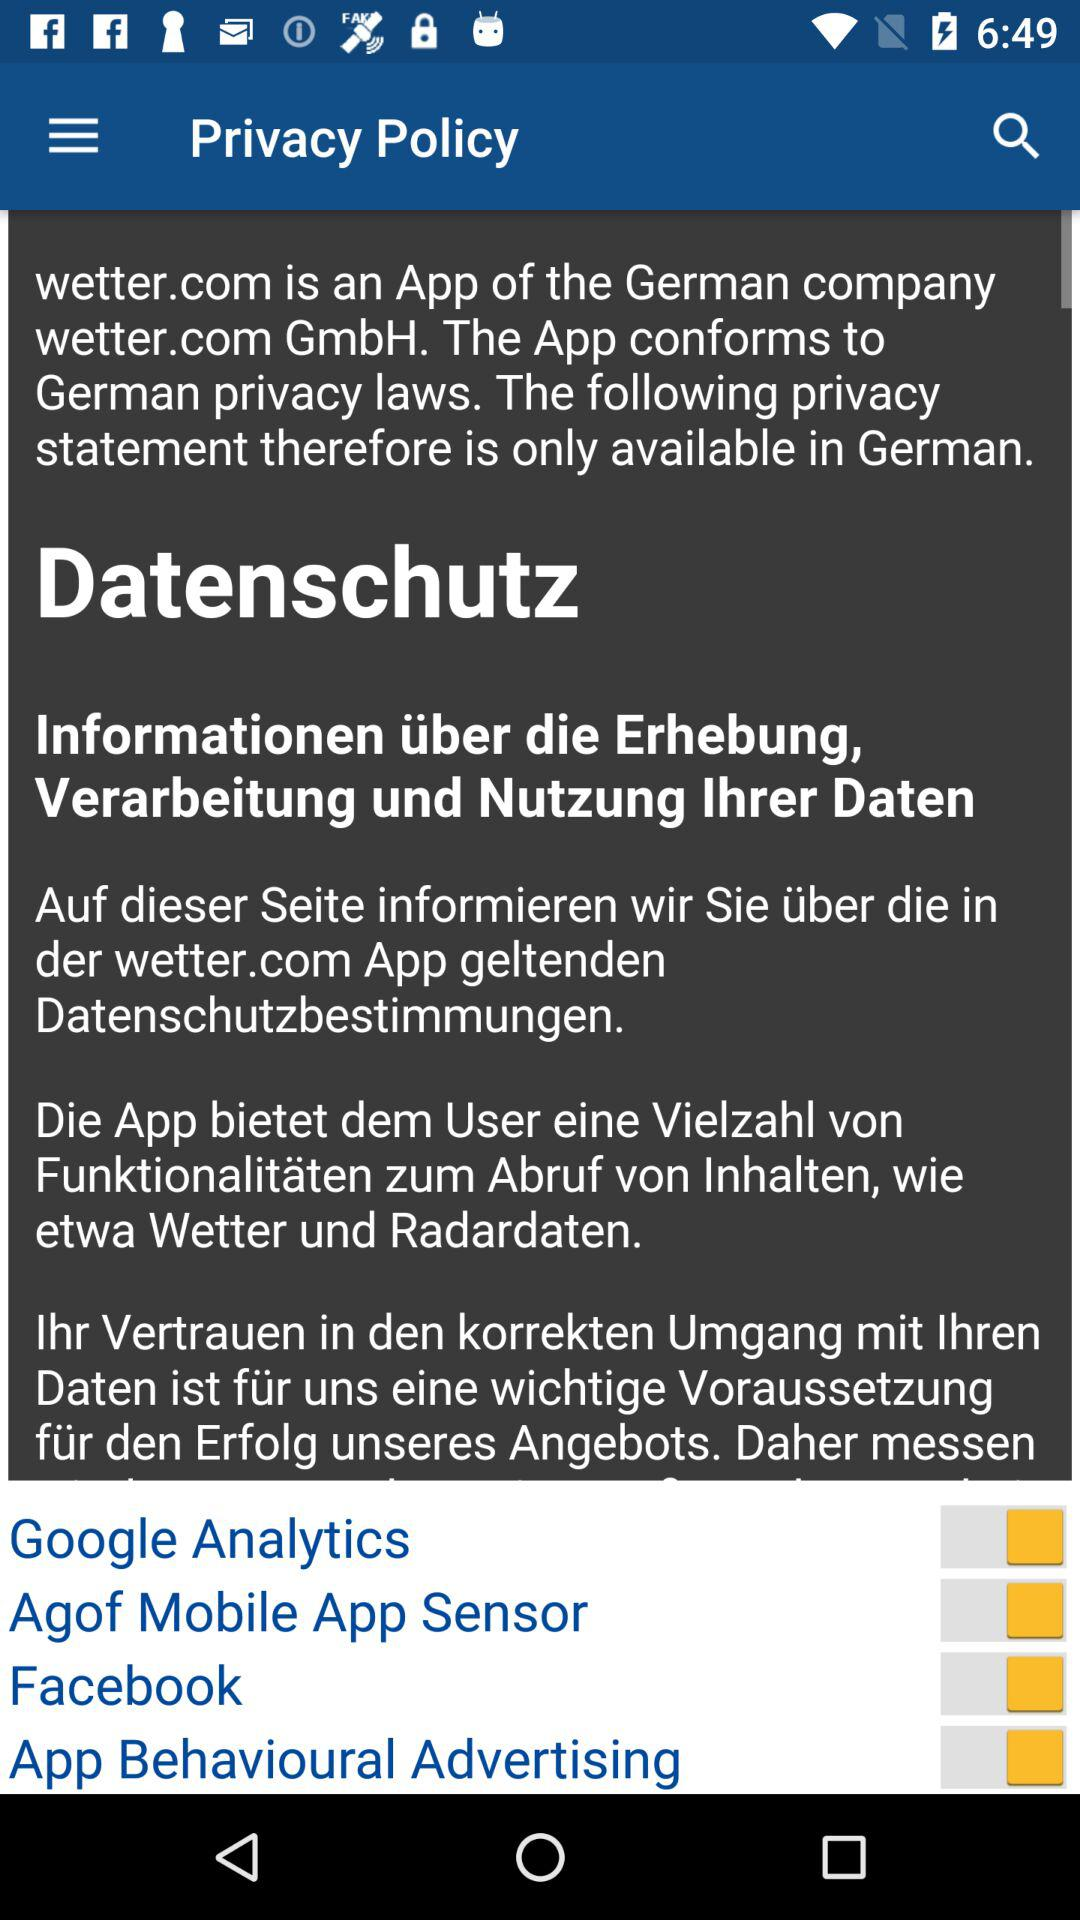What is the status of Google Analytics? The status is on. 